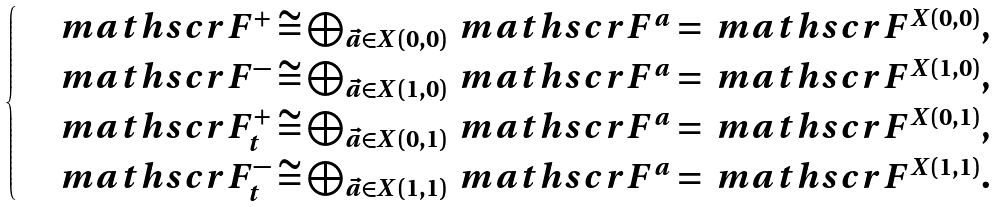Convert formula to latex. <formula><loc_0><loc_0><loc_500><loc_500>\begin{cases} & \ m a t h s c r { F } ^ { + } \cong \bigoplus _ { \vec { a } \in X ( 0 , 0 ) } \ m a t h s c r { F } ^ { a } = \ m a t h s c r { F } ^ { X ( 0 , 0 ) } , \\ & \ m a t h s c r { F } ^ { - } \cong \bigoplus _ { \vec { a } \in X ( 1 , 0 ) } \ m a t h s c r { F } ^ { a } = \ m a t h s c r { F } ^ { X ( 1 , 0 ) } , \\ & \ m a t h s c r { F } ^ { + } _ { t } \cong \bigoplus _ { \vec { a } \in X ( 0 , 1 ) } \ m a t h s c r { F } ^ { a } = \ m a t h s c r { F } ^ { X ( 0 , 1 ) } , \\ & \ m a t h s c r { F } ^ { - } _ { t } \cong \bigoplus _ { \vec { a } \in X ( 1 , 1 ) } \ m a t h s c r { F } ^ { a } = \ m a t h s c r { F } ^ { X ( 1 , 1 ) } . \end{cases}</formula> 